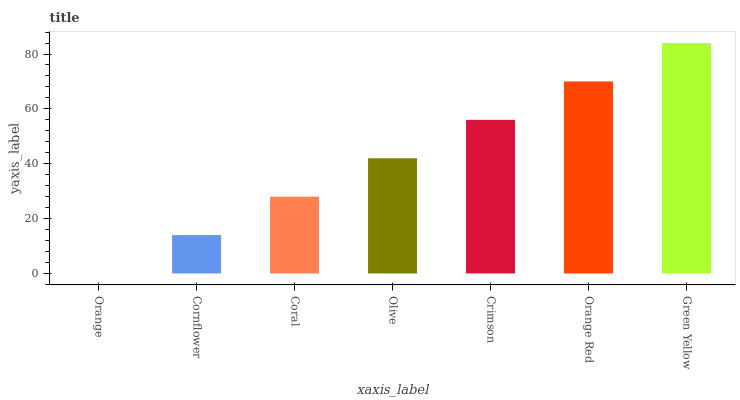Is Orange the minimum?
Answer yes or no. Yes. Is Green Yellow the maximum?
Answer yes or no. Yes. Is Cornflower the minimum?
Answer yes or no. No. Is Cornflower the maximum?
Answer yes or no. No. Is Cornflower greater than Orange?
Answer yes or no. Yes. Is Orange less than Cornflower?
Answer yes or no. Yes. Is Orange greater than Cornflower?
Answer yes or no. No. Is Cornflower less than Orange?
Answer yes or no. No. Is Olive the high median?
Answer yes or no. Yes. Is Olive the low median?
Answer yes or no. Yes. Is Orange Red the high median?
Answer yes or no. No. Is Coral the low median?
Answer yes or no. No. 